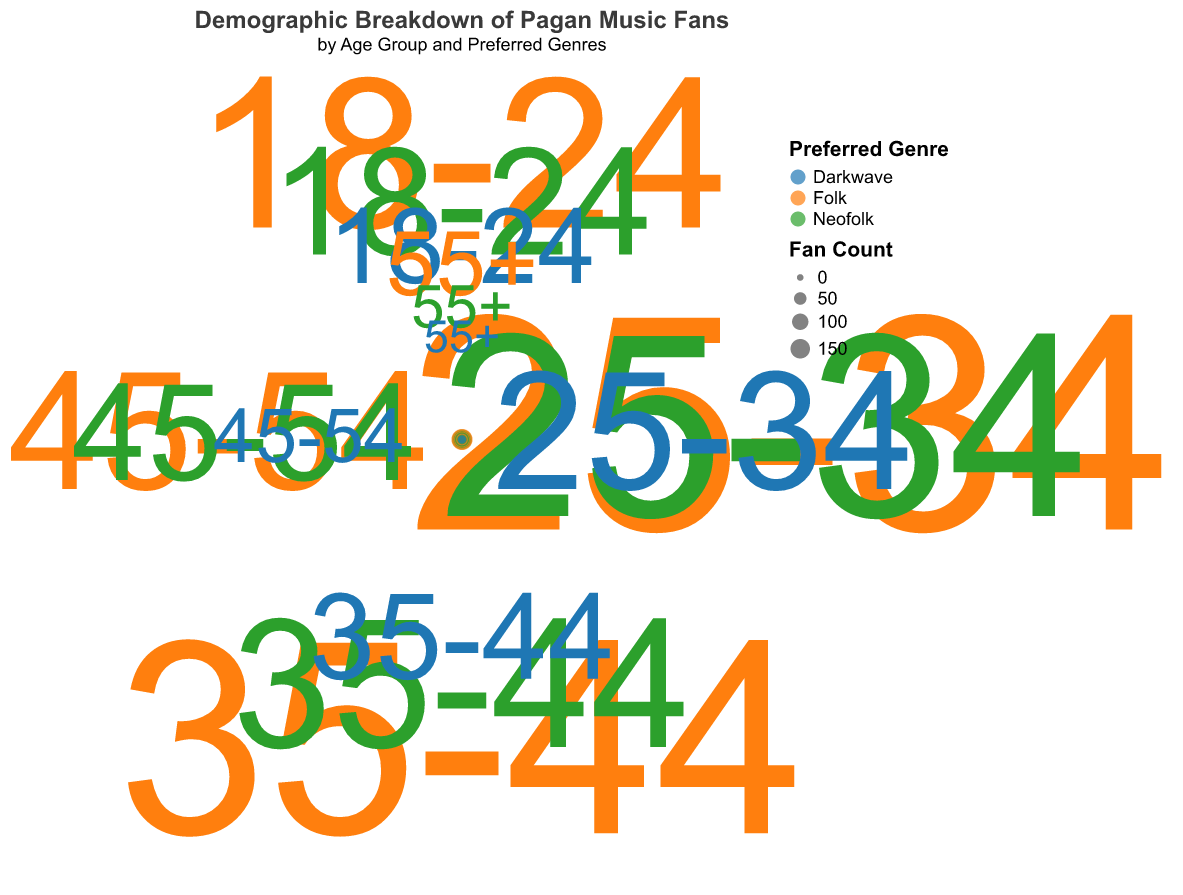Which age group has the largest fan count for folk music? Look at the points related to the "Folk" genre and compare the fan counts across age groups. The 25-34 age group has the largest fan count, with a radius corresponding to a fan count of 180.
Answer: 25-34 How does the number of folk music fans in the 18-24 age group compare to the number of neofolk fans in the same age group? Check the fan counts for "Folk" and "Neofolk" within the 18-24 age group. The fan count for folk is 120 and for neofolk is 80. Comparing these, folk has more fans (120 vs. 80).
Answer: Folk has more fans What is the total fan count for the 35-44 age group across all genres? Sum the fan counts for "Folk," "Neofolk," and "Darkwave" in the 35-44 age group. That's 160 + 100 + 60 = 320.
Answer: 320 Which age group has the smallest representation for the Darkwave genre? Compare the smallest points (in radius/size) for "Darkwave" across all age groups. The smallest representation is in the 55+ age group with a fan count of 10.
Answer: 55+ Between the 25-34 and 45-54 age groups, which one has a higher average fan count across all genres? Calculate the average fan count for both age groups. For 25-34: (180+150+90)/3 = 140. For 45-54: (90+70+30)/3 = 63.33. The 25-34 age group has a higher average.
Answer: 25-34 For which genre does the 25-34 age group have the highest fan count? Identify the largest point in the radius for the 25-34 age group and see which genre it corresponds to. The largest radius corresponds to "Folk" with 180 fans.
Answer: Folk What is the total fan count for neofolk across all age groups? Sum the fan counts for "Neofolk" across all age groups: 80 + 150 + 100 + 70 + 20 = 420.
Answer: 420 Which preferred genre is least popular among the 45-54 age group? Compare fan counts for "Folk," "Neofolk," and "Darkwave" in the 45-54 age group. The smallest fan count is for "Darkwave" with 30 fans.
Answer: Darkwave 